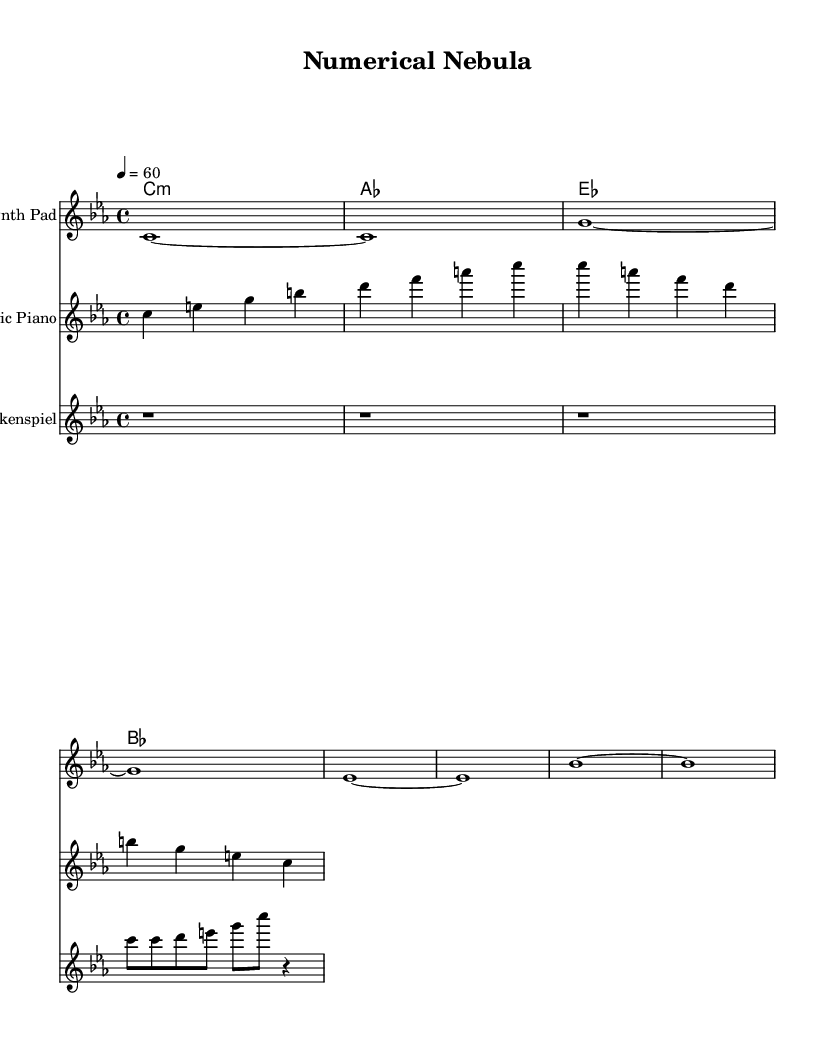What is the key signature of this music? The key signature is indicated by the presence of flat symbols in the sheet music. Here, the key signature shows three flats (B flat, E flat, and A flat), which corresponds to C minor.
Answer: C minor What is the time signature of this piece? The time signature is found at the beginning of the staff, represented as a fraction. In this music, it is shown as 4 over 4.
Answer: 4/4 What is the tempo marking for this music? The tempo marking is specified within the global settings at the beginning of the score. It is noted as "4 = 60", indicating the beats per minute.
Answer: 60 Which instrument has the highest pitch range? To determine this, we observe the range of notes played by each instrument staff. The glockenspiel generally plays higher pitches than the synthesizer or piano, particularly given its higher relative octave.
Answer: Glockenspiel How many measures are in the synth line? We can count the measures in the synth line by observing the bar lines that separate the musical phrases. The synth line has a total of eight measures.
Answer: 8 What type of chords are used in this music? The chord names appear above the staff and indicate the nature of the chords played. The chords include minor and major formats, with a specific presence of a C minor chord at the start, followed by varying qualities in subsequent chords.
Answer: Minor and major Which section of the music has a rest? The rest is indicated by the presence of a 'r' symbol in the sheet music. In the glockenspiel part, there are three measures of rests initially before the melodic section begins.
Answer: First section 